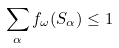<formula> <loc_0><loc_0><loc_500><loc_500>\sum _ { \alpha } f _ { \omega } ( S _ { \alpha } ) \leq 1</formula> 